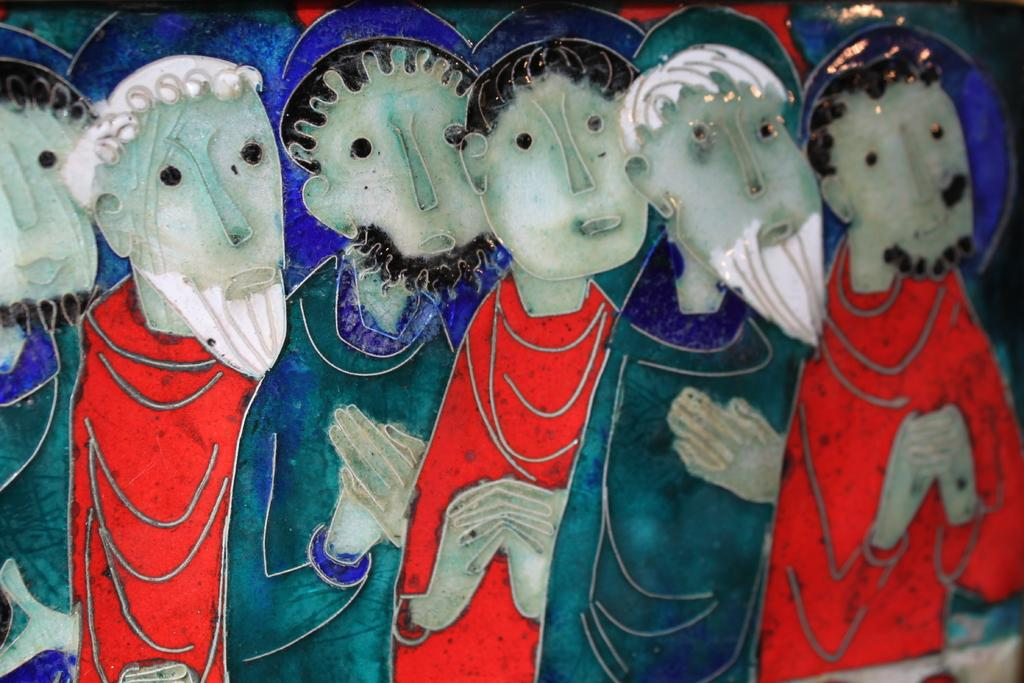What type of objects are present in the image? There are handicrafts in the image. How does the boy fall from the heat in the image? There is no boy or heat present in the image; it only features handicrafts. 